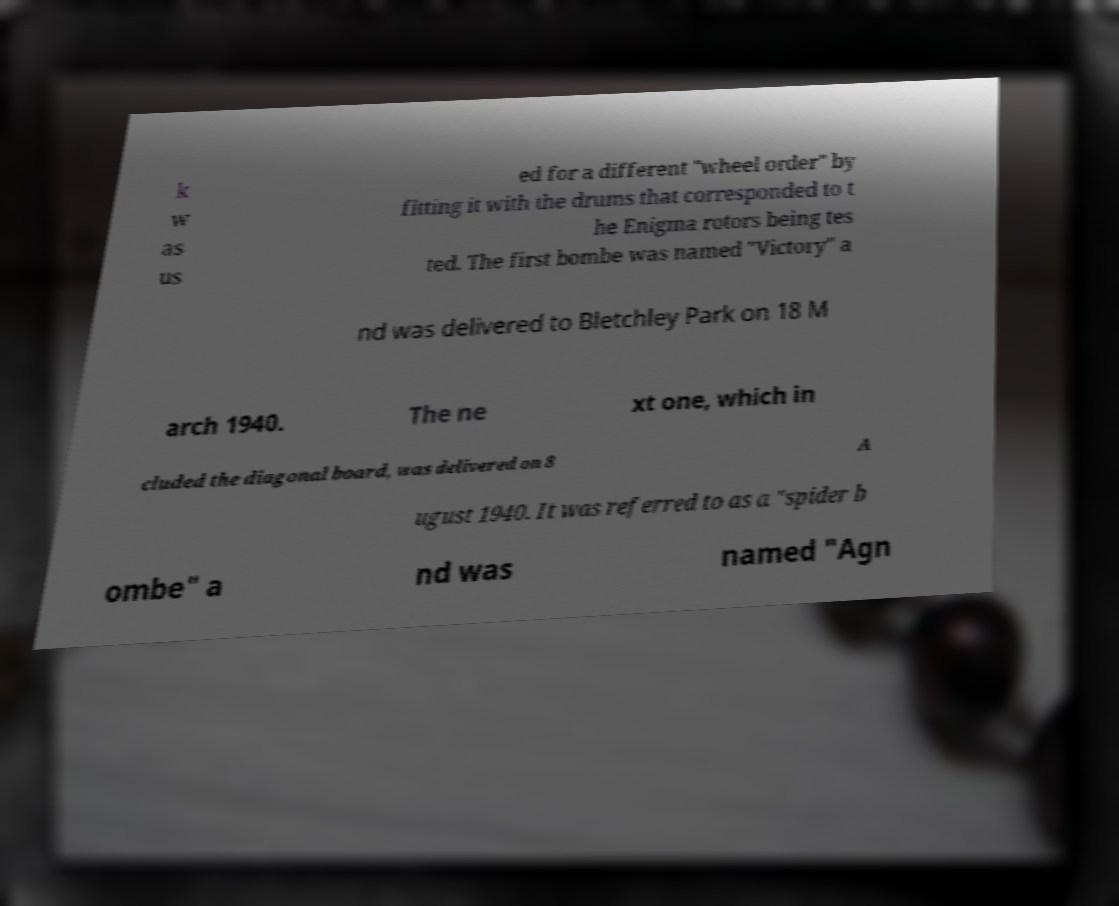Can you accurately transcribe the text from the provided image for me? k w as us ed for a different "wheel order" by fitting it with the drums that corresponded to t he Enigma rotors being tes ted. The first bombe was named "Victory" a nd was delivered to Bletchley Park on 18 M arch 1940. The ne xt one, which in cluded the diagonal board, was delivered on 8 A ugust 1940. It was referred to as a "spider b ombe" a nd was named "Agn 